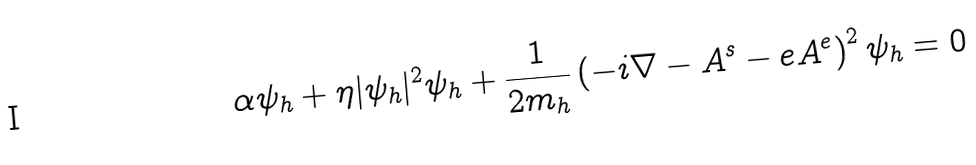<formula> <loc_0><loc_0><loc_500><loc_500>\alpha \psi _ { h } + \eta | \psi _ { h } | ^ { 2 } \psi _ { h } + \frac { 1 } { 2 m _ { h } } \left ( - i \nabla - A ^ { s } - e A ^ { e } \right ) ^ { 2 } \psi _ { h } = 0</formula> 